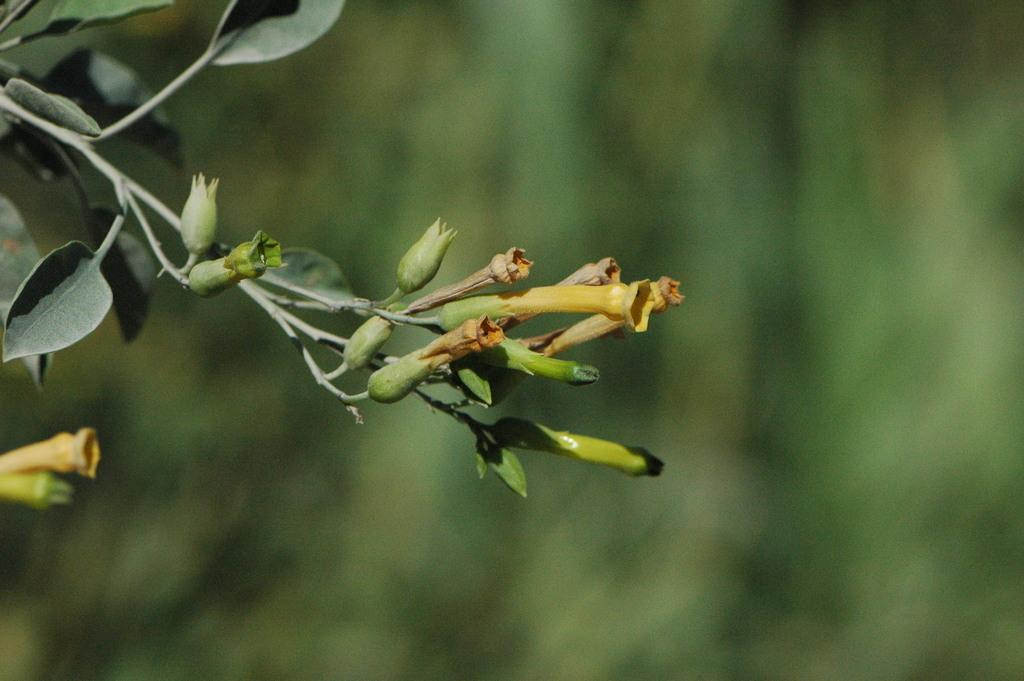What color are the leaves and buds in the image? The leaves and buds in the image are green. What can be inferred about the overall color scheme of the image? The background of the image is also green. How is the image's background depicted? The background of the image is blurry. How many rings can be seen on the ants in the image? There are no ants present in the image, so there are no rings to count. What type of garden is visible in the image? There is no garden depicted in the image; it primarily features green leaves, buds, and a blurry background. 